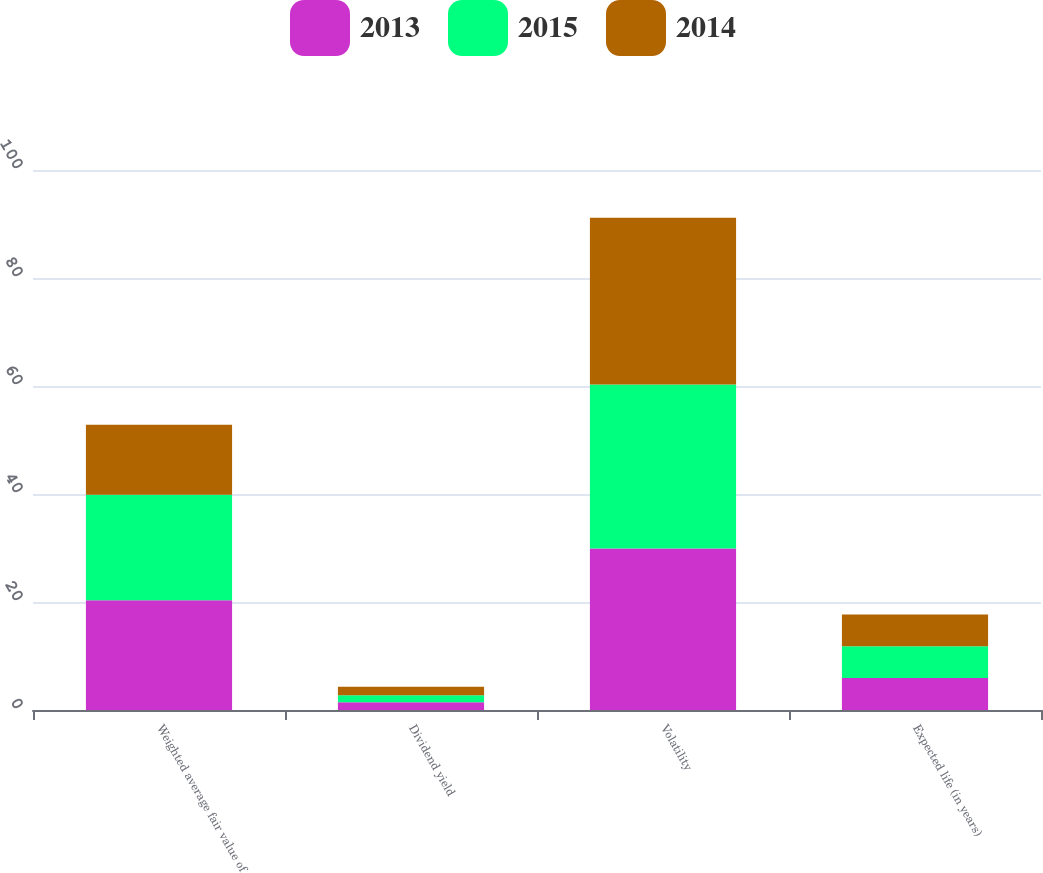Convert chart to OTSL. <chart><loc_0><loc_0><loc_500><loc_500><stacked_bar_chart><ecel><fcel>Weighted average fair value of<fcel>Dividend yield<fcel>Volatility<fcel>Expected life (in years)<nl><fcel>2013<fcel>20.32<fcel>1.45<fcel>29.9<fcel>5.93<nl><fcel>2015<fcel>19.52<fcel>1.27<fcel>30.36<fcel>5.89<nl><fcel>2014<fcel>12.97<fcel>1.57<fcel>30.92<fcel>5.86<nl></chart> 